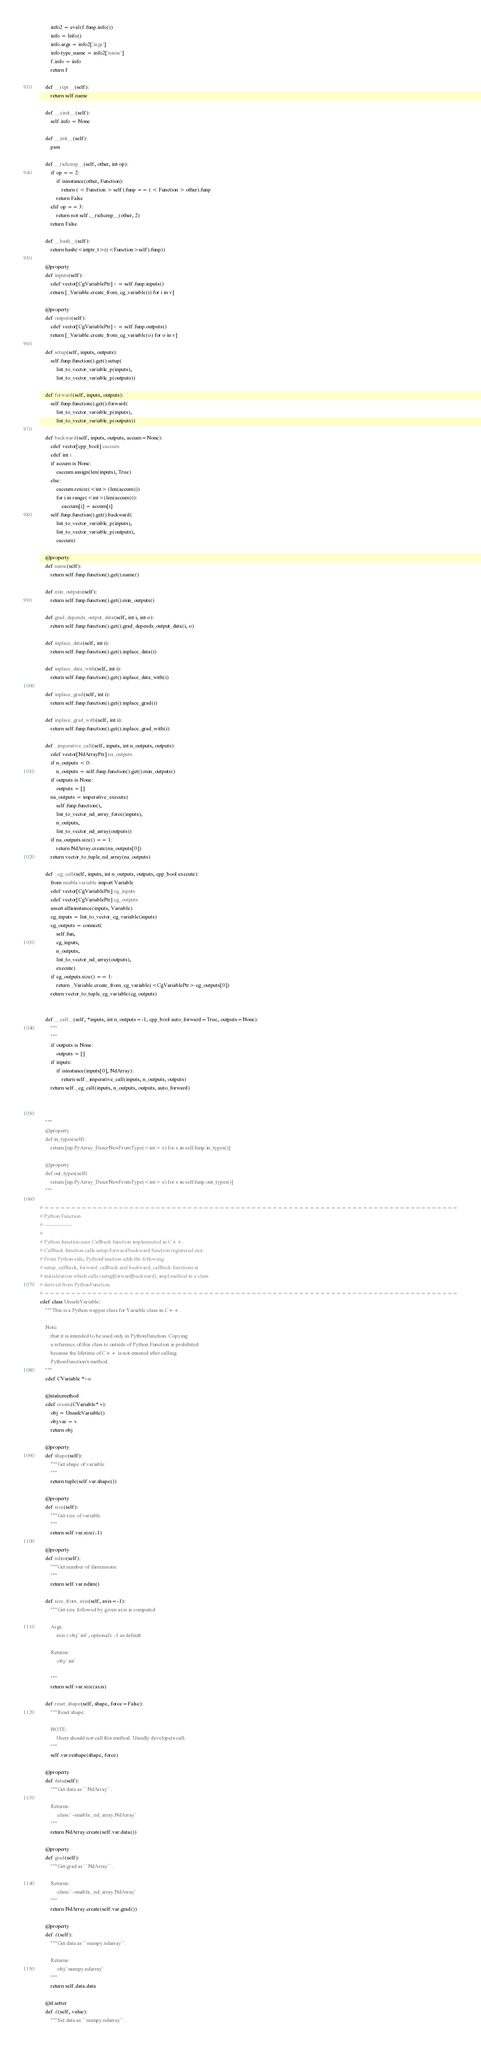Convert code to text. <code><loc_0><loc_0><loc_500><loc_500><_Cython_>        info2 = eval(f.funp.info())
        info = Info()
        info.args = info2['args']
        info.type_name = info2['name']
        f.info = info
        return f

    def __repr__(self):
        return self.name

    def __cinit__(self):
        self.info = None

    def __init__(self):
        pass

    def __richcmp__(self, other, int op):
        if op == 2:
            if isinstance(other, Function):
                return ( < Function > self).funp == ( < Function > other).funp
            return False
        elif op == 3:
            return not self.__richcmp__(other, 2)
        return False

    def __hash__(self):
        return hash(<intptr_t>((<Function>self).funp))

    @property
    def inputs(self):
        cdef vector[CgVariablePtr] v = self.funp.inputs()
        return [_Variable.create_from_cg_variable(i) for i in v]

    @property
    def outputs(self):
        cdef vector[CgVariablePtr] v = self.funp.outputs()
        return [_Variable.create_from_cg_variable(o) for o in v]

    def setup(self, inputs, outputs):
        self.funp.function().get().setup(
            list_to_vector_variable_p(inputs),
            list_to_vector_variable_p(outputs))

    def forward(self, inputs, outputs):
        self.funp.function().get().forward(
            list_to_vector_variable_p(inputs),
            list_to_vector_variable_p(outputs))

    def backward(self, inputs, outputs, accum=None):
        cdef vector[cpp_bool] caccum
        cdef int i
        if accum is None:
            caccum.assign(len(inputs), True)
        else:
            caccum.resize(<int> (len(accum)))
            for i in range(<int>(len(accum))):
                caccum[i] = accum[i]
        self.funp.function().get().backward(
            list_to_vector_variable_p(inputs),
            list_to_vector_variable_p(outputs),
            caccum)

    @property
    def name(self):
        return self.funp.function().get().name()

    def min_outputs(self):
        return self.funp.function().get().min_outputs()

    def grad_depends_output_data(self, int i, int o):
        return self.funp.function().get().grad_depends_output_data(i, o)

    def inplace_data(self, int i):
        return self.funp.function().get().inplace_data(i)

    def inplace_data_with(self, int i):
        return self.funp.function().get().inplace_data_with(i)

    def inplace_grad(self, int i):
        return self.funp.function().get().inplace_grad(i)

    def inplace_grad_with(self, int i):
        return self.funp.function().get().inplace_grad_with(i)

    def _imperative_call(self, inputs, int n_outputs, outputs):
        cdef vector[NdArrayPtr] na_outputs
        if n_outputs < 0:
            n_outputs = self.funp.function().get().min_outputs()
        if outputs is None:
            outputs = []
        na_outputs = imperative_execute(
            self.funp.function(),
            list_to_vector_nd_array_force(inputs),
            n_outputs,
            list_to_vector_nd_array(outputs))
        if na_outputs.size() == 1:
            return NdArray.create(na_outputs[0])
        return vector_to_tuple_nd_array(na_outputs)

    def _cg_call(self, inputs, int n_outputs, outputs, cpp_bool execute):
        from nnabla.variable import Variable
        cdef vector[CgVariablePtr] cg_inputs 
        cdef vector[CgVariablePtr] cg_outputs
        assert allisinstance(inputs, Variable)
        cg_inputs = list_to_vector_cg_variable(inputs)
        cg_outputs = connect(
            self.fun,
            cg_inputs,
            n_outputs,
            list_to_vector_nd_array(outputs),
            execute)
        if cg_outputs.size() == 1:
            return _Variable.create_from_cg_variable(<CgVariablePtr> cg_outputs[0])
        return vector_to_tuple_cg_variable(cg_outputs)

                                
    def __call__(self, *inputs, int n_outputs=-1, cpp_bool auto_forward=True, outputs=None):
        """
        """
        if outputs is None:
            outputs = []
        if inputs:
            if isinstance(inputs[0], NdArray):
                return self._imperative_call(inputs, n_outputs, outputs)
        return self._cg_call(inputs, n_outputs, outputs, auto_forward)

        

    """
    @property
    def in_types(self):
        return [np.PyArray_DescrNewFromType(<int> x) for x in self.funp.in_types()]

    @property
    def out_types(self):
        return [np.PyArray_DescrNewFromType(<int> x) for x in self.funp.out_types()]
    """

# ==============================================================================
# Python Function
# ---------------
#
# Python function uses Callback function implemneted in C++.
# Callback function calls setup/forward/backward function registered ctor.
# From Python side, PythonFunction adds the following
# setup_callback, forward_callback and backward_callback functions at
# initialization which calls (setup|forward|backward)_impl method in a class
# derived from PythonFunction.
# ==============================================================================
cdef class UnsafeVariable:
    """This is a Python wapper class for Variable class in C++.

    Note:
        that it is intended to be used only in PythonFunction. Copying
        a reference of this class to outside of Python Function is prohibited
        because the lifetime of C++ is not ensured after calling
        PythonFunction's method.
    """
    cdef CVariable *var

    @staticmethod
    cdef create(CVariable* v):
        obj = UnsafeVariable()
        obj.var = v
        return obj

    @property
    def shape(self):
        """Get shape of variable
        """
        return tuple(self.var.shape())

    @property
    def size(self):
        """Get size of variable
        """
        return self.var.size(-1)

    @property
    def ndim(self):
        """Get number of dimensions.
        """
        return self.var.ndim()

    def size_from_axis(self, axis=-1):
        """Get size followed by given axis is computed

        Args:
            axis (:obj:`int`, optional): -1 as default

        Returns:
            :obj:`int`

        """
        return self.var.size(axis)

    def reset_shape(self, shape, force=False):
        """Reset shape.

        NOTE:
            Users should not call this method. Usually developers call.
        """
        self.var.reshape(shape, force)

    @property
    def data(self):
        """Get data as ``NdArray``.

        Returns:
            :class:`~nnabla._nd_array.NdArray`
        """
        return NdArray.create(self.var.data())

    @property
    def grad(self):
        """Get grad as ``NdArray``.

        Returns:
            :class:`~nnabla._nd_array.NdArray`
        """
        return NdArray.create(self.var.grad())

    @property
    def d(self):
        """Get data as ``numpy.ndarray``.

        Returns:
            :obj:`numpy.ndarray`
        """
        return self.data.data

    @d.setter
    def d(self, value):
        """Set data as ``numpy.ndarray``.
</code> 